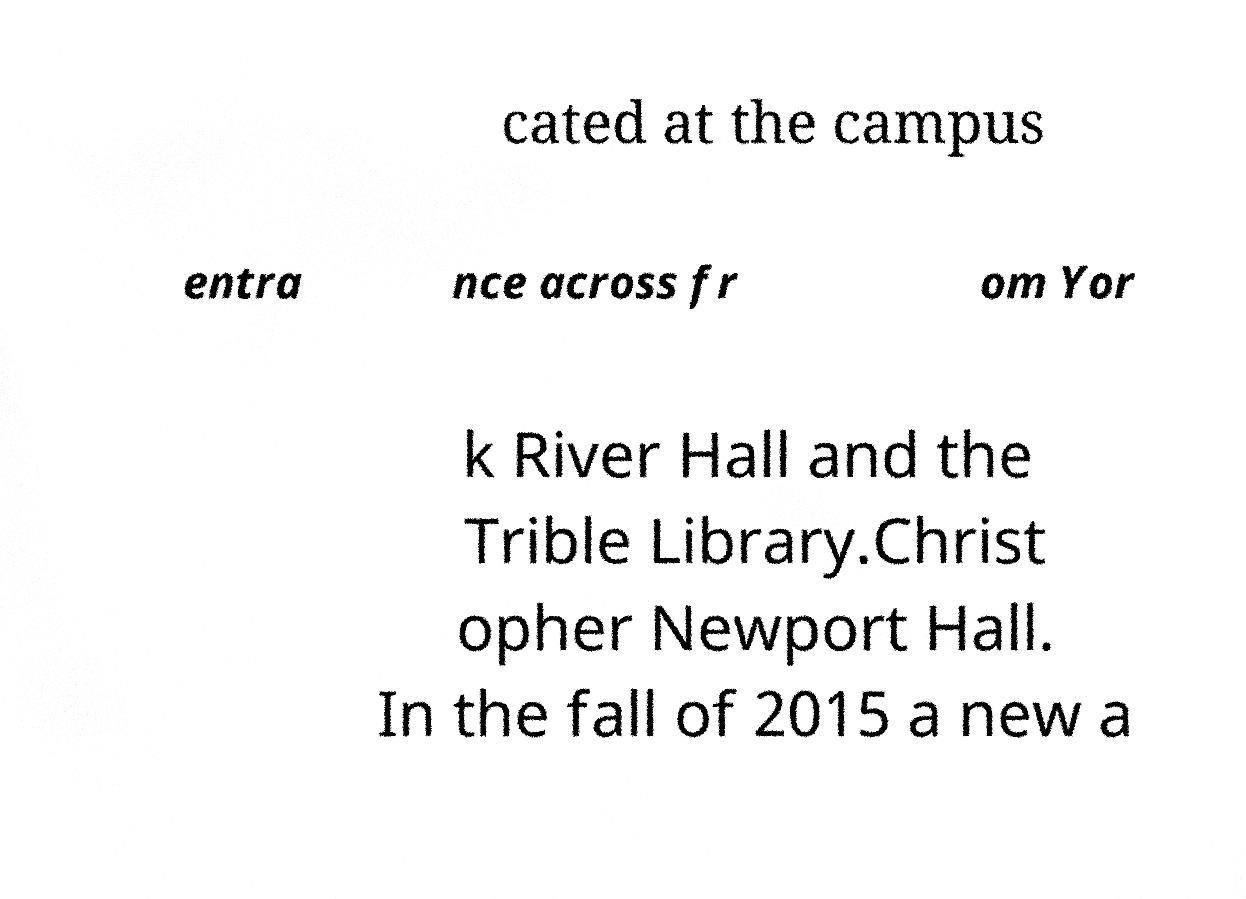Please identify and transcribe the text found in this image. cated at the campus entra nce across fr om Yor k River Hall and the Trible Library.Christ opher Newport Hall. In the fall of 2015 a new a 